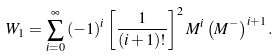<formula> <loc_0><loc_0><loc_500><loc_500>W _ { 1 } = \sum _ { i = 0 } ^ { \infty } \, ( - 1 ) ^ { i } \left [ \frac { 1 } { ( i + 1 ) ! } \right ] ^ { 2 } M ^ { i } \left ( M ^ { - } \right ) ^ { i + 1 } .</formula> 